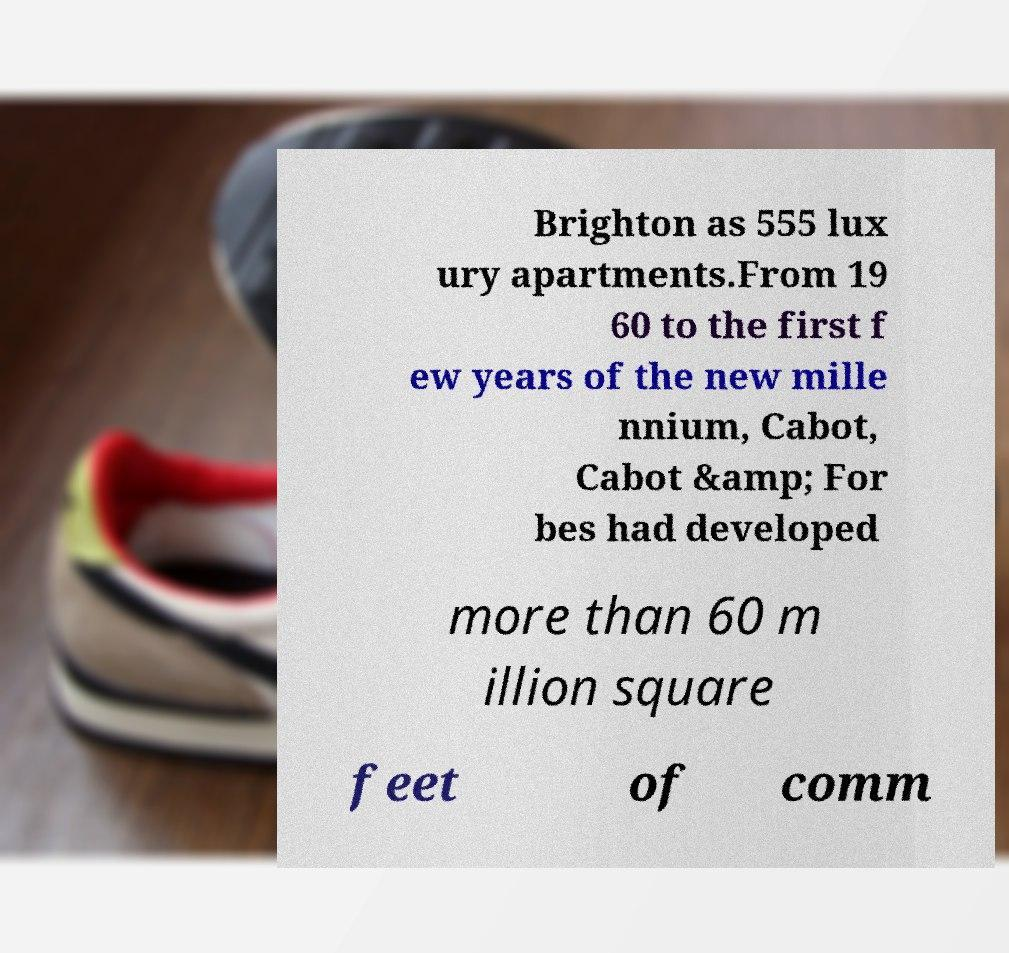Can you read and provide the text displayed in the image?This photo seems to have some interesting text. Can you extract and type it out for me? Brighton as 555 lux ury apartments.From 19 60 to the first f ew years of the new mille nnium, Cabot, Cabot &amp; For bes had developed more than 60 m illion square feet of comm 